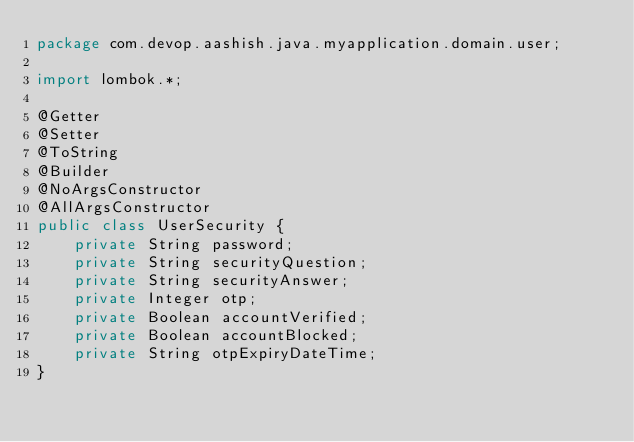<code> <loc_0><loc_0><loc_500><loc_500><_Java_>package com.devop.aashish.java.myapplication.domain.user;

import lombok.*;

@Getter
@Setter
@ToString
@Builder
@NoArgsConstructor
@AllArgsConstructor
public class UserSecurity {
    private String password;
    private String securityQuestion;
    private String securityAnswer;
    private Integer otp;
    private Boolean accountVerified;
    private Boolean accountBlocked;
    private String otpExpiryDateTime;
}
</code> 